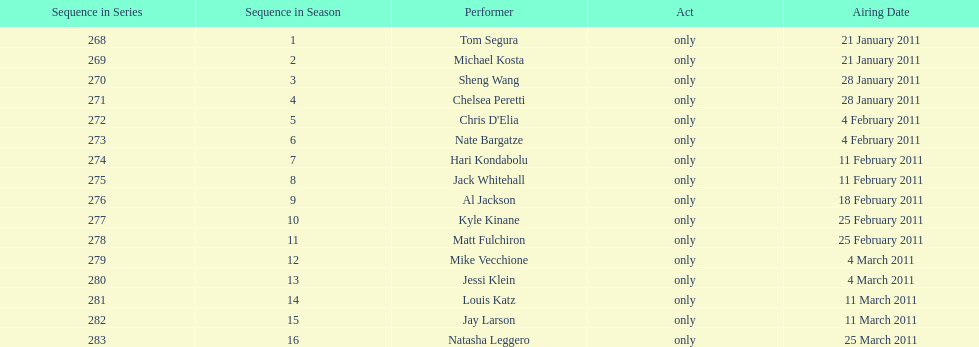What was hari's last name? Kondabolu. Could you help me parse every detail presented in this table? {'header': ['Sequence in Series', 'Sequence in Season', 'Performer', 'Act', 'Airing Date'], 'rows': [['268', '1', 'Tom Segura', 'only', '21 January 2011'], ['269', '2', 'Michael Kosta', 'only', '21 January 2011'], ['270', '3', 'Sheng Wang', 'only', '28 January 2011'], ['271', '4', 'Chelsea Peretti', 'only', '28 January 2011'], ['272', '5', "Chris D'Elia", 'only', '4 February 2011'], ['273', '6', 'Nate Bargatze', 'only', '4 February 2011'], ['274', '7', 'Hari Kondabolu', 'only', '11 February 2011'], ['275', '8', 'Jack Whitehall', 'only', '11 February 2011'], ['276', '9', 'Al Jackson', 'only', '18 February 2011'], ['277', '10', 'Kyle Kinane', 'only', '25 February 2011'], ['278', '11', 'Matt Fulchiron', 'only', '25 February 2011'], ['279', '12', 'Mike Vecchione', 'only', '4 March 2011'], ['280', '13', 'Jessi Klein', 'only', '4 March 2011'], ['281', '14', 'Louis Katz', 'only', '11 March 2011'], ['282', '15', 'Jay Larson', 'only', '11 March 2011'], ['283', '16', 'Natasha Leggero', 'only', '25 March 2011']]} 